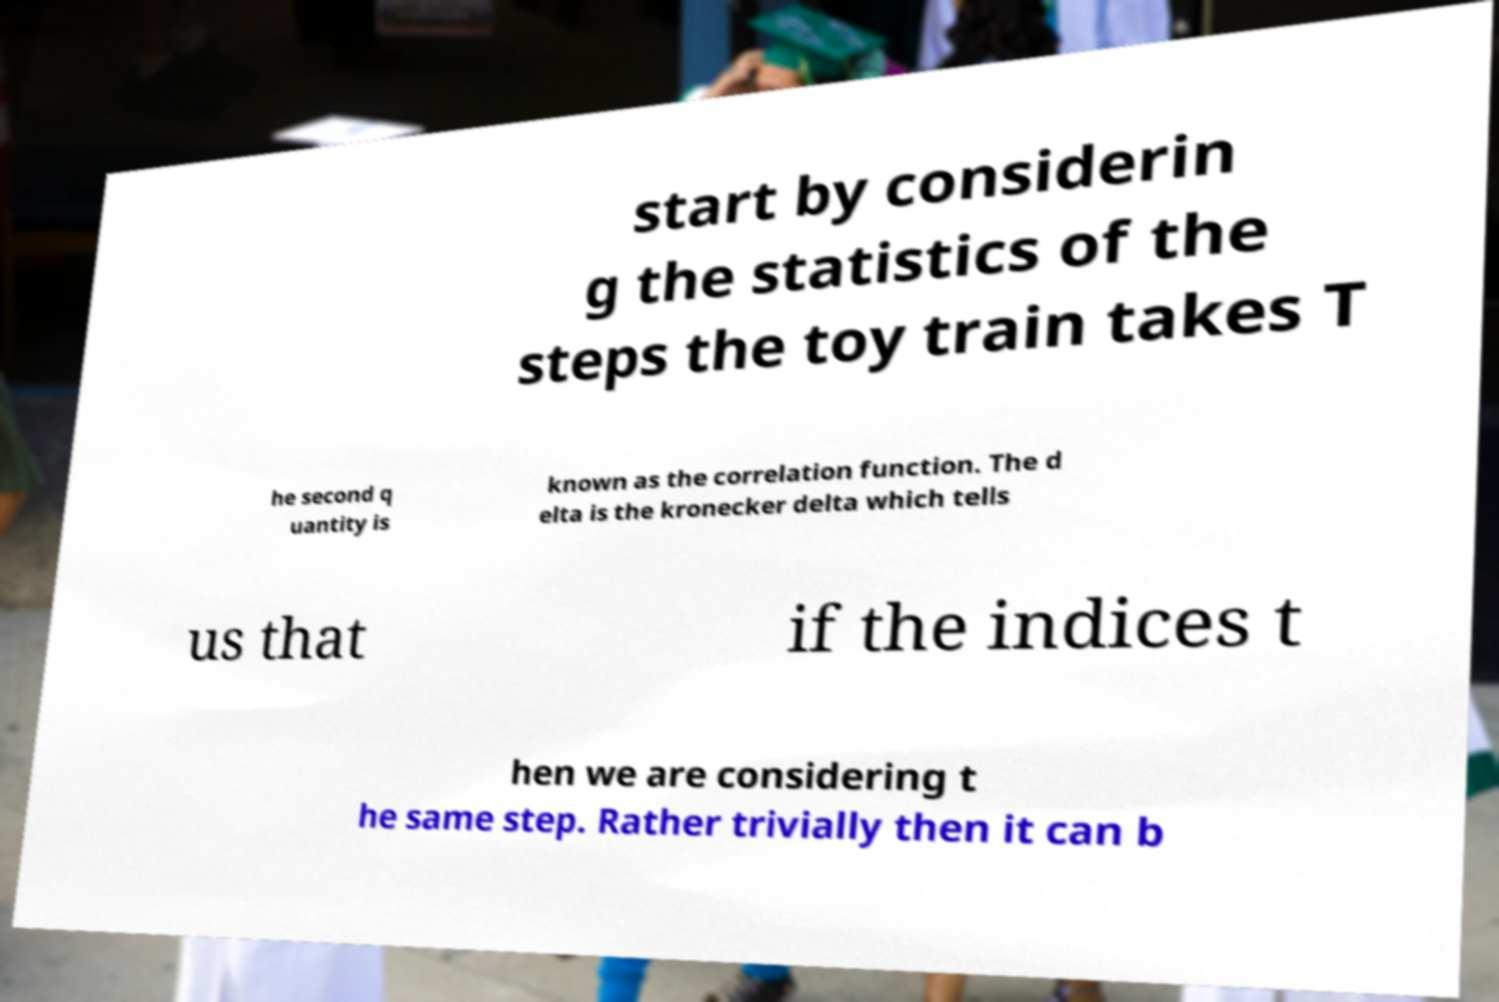There's text embedded in this image that I need extracted. Can you transcribe it verbatim? start by considerin g the statistics of the steps the toy train takes T he second q uantity is known as the correlation function. The d elta is the kronecker delta which tells us that if the indices t hen we are considering t he same step. Rather trivially then it can b 